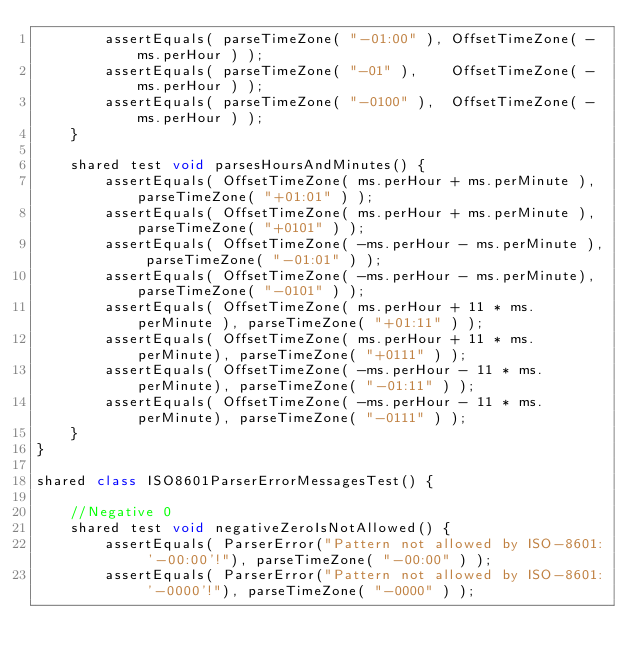Convert code to text. <code><loc_0><loc_0><loc_500><loc_500><_Ceylon_>        assertEquals( parseTimeZone( "-01:00" ), OffsetTimeZone( -ms.perHour ) );
        assertEquals( parseTimeZone( "-01" ),    OffsetTimeZone( -ms.perHour ) );
        assertEquals( parseTimeZone( "-0100" ),  OffsetTimeZone( -ms.perHour ) );
    }

    shared test void parsesHoursAndMinutes() {
        assertEquals( OffsetTimeZone( ms.perHour + ms.perMinute ), parseTimeZone( "+01:01" ) );
        assertEquals( OffsetTimeZone( ms.perHour + ms.perMinute ), parseTimeZone( "+0101" ) );
        assertEquals( OffsetTimeZone( -ms.perHour - ms.perMinute ), parseTimeZone( "-01:01" ) );
        assertEquals( OffsetTimeZone( -ms.perHour - ms.perMinute), parseTimeZone( "-0101" ) );
        assertEquals( OffsetTimeZone( ms.perHour + 11 * ms.perMinute ), parseTimeZone( "+01:11" ) );
        assertEquals( OffsetTimeZone( ms.perHour + 11 * ms.perMinute), parseTimeZone( "+0111" ) );
        assertEquals( OffsetTimeZone( -ms.perHour - 11 * ms.perMinute), parseTimeZone( "-01:11" ) );
        assertEquals( OffsetTimeZone( -ms.perHour - 11 * ms.perMinute), parseTimeZone( "-0111" ) );
    }
}

shared class ISO8601ParserErrorMessagesTest() {
    
    //Negative 0
    shared test void negativeZeroIsNotAllowed() {
        assertEquals( ParserError("Pattern not allowed by ISO-8601: '-00:00'!"), parseTimeZone( "-00:00" ) );
        assertEquals( ParserError("Pattern not allowed by ISO-8601: '-0000'!"), parseTimeZone( "-0000" ) );</code> 